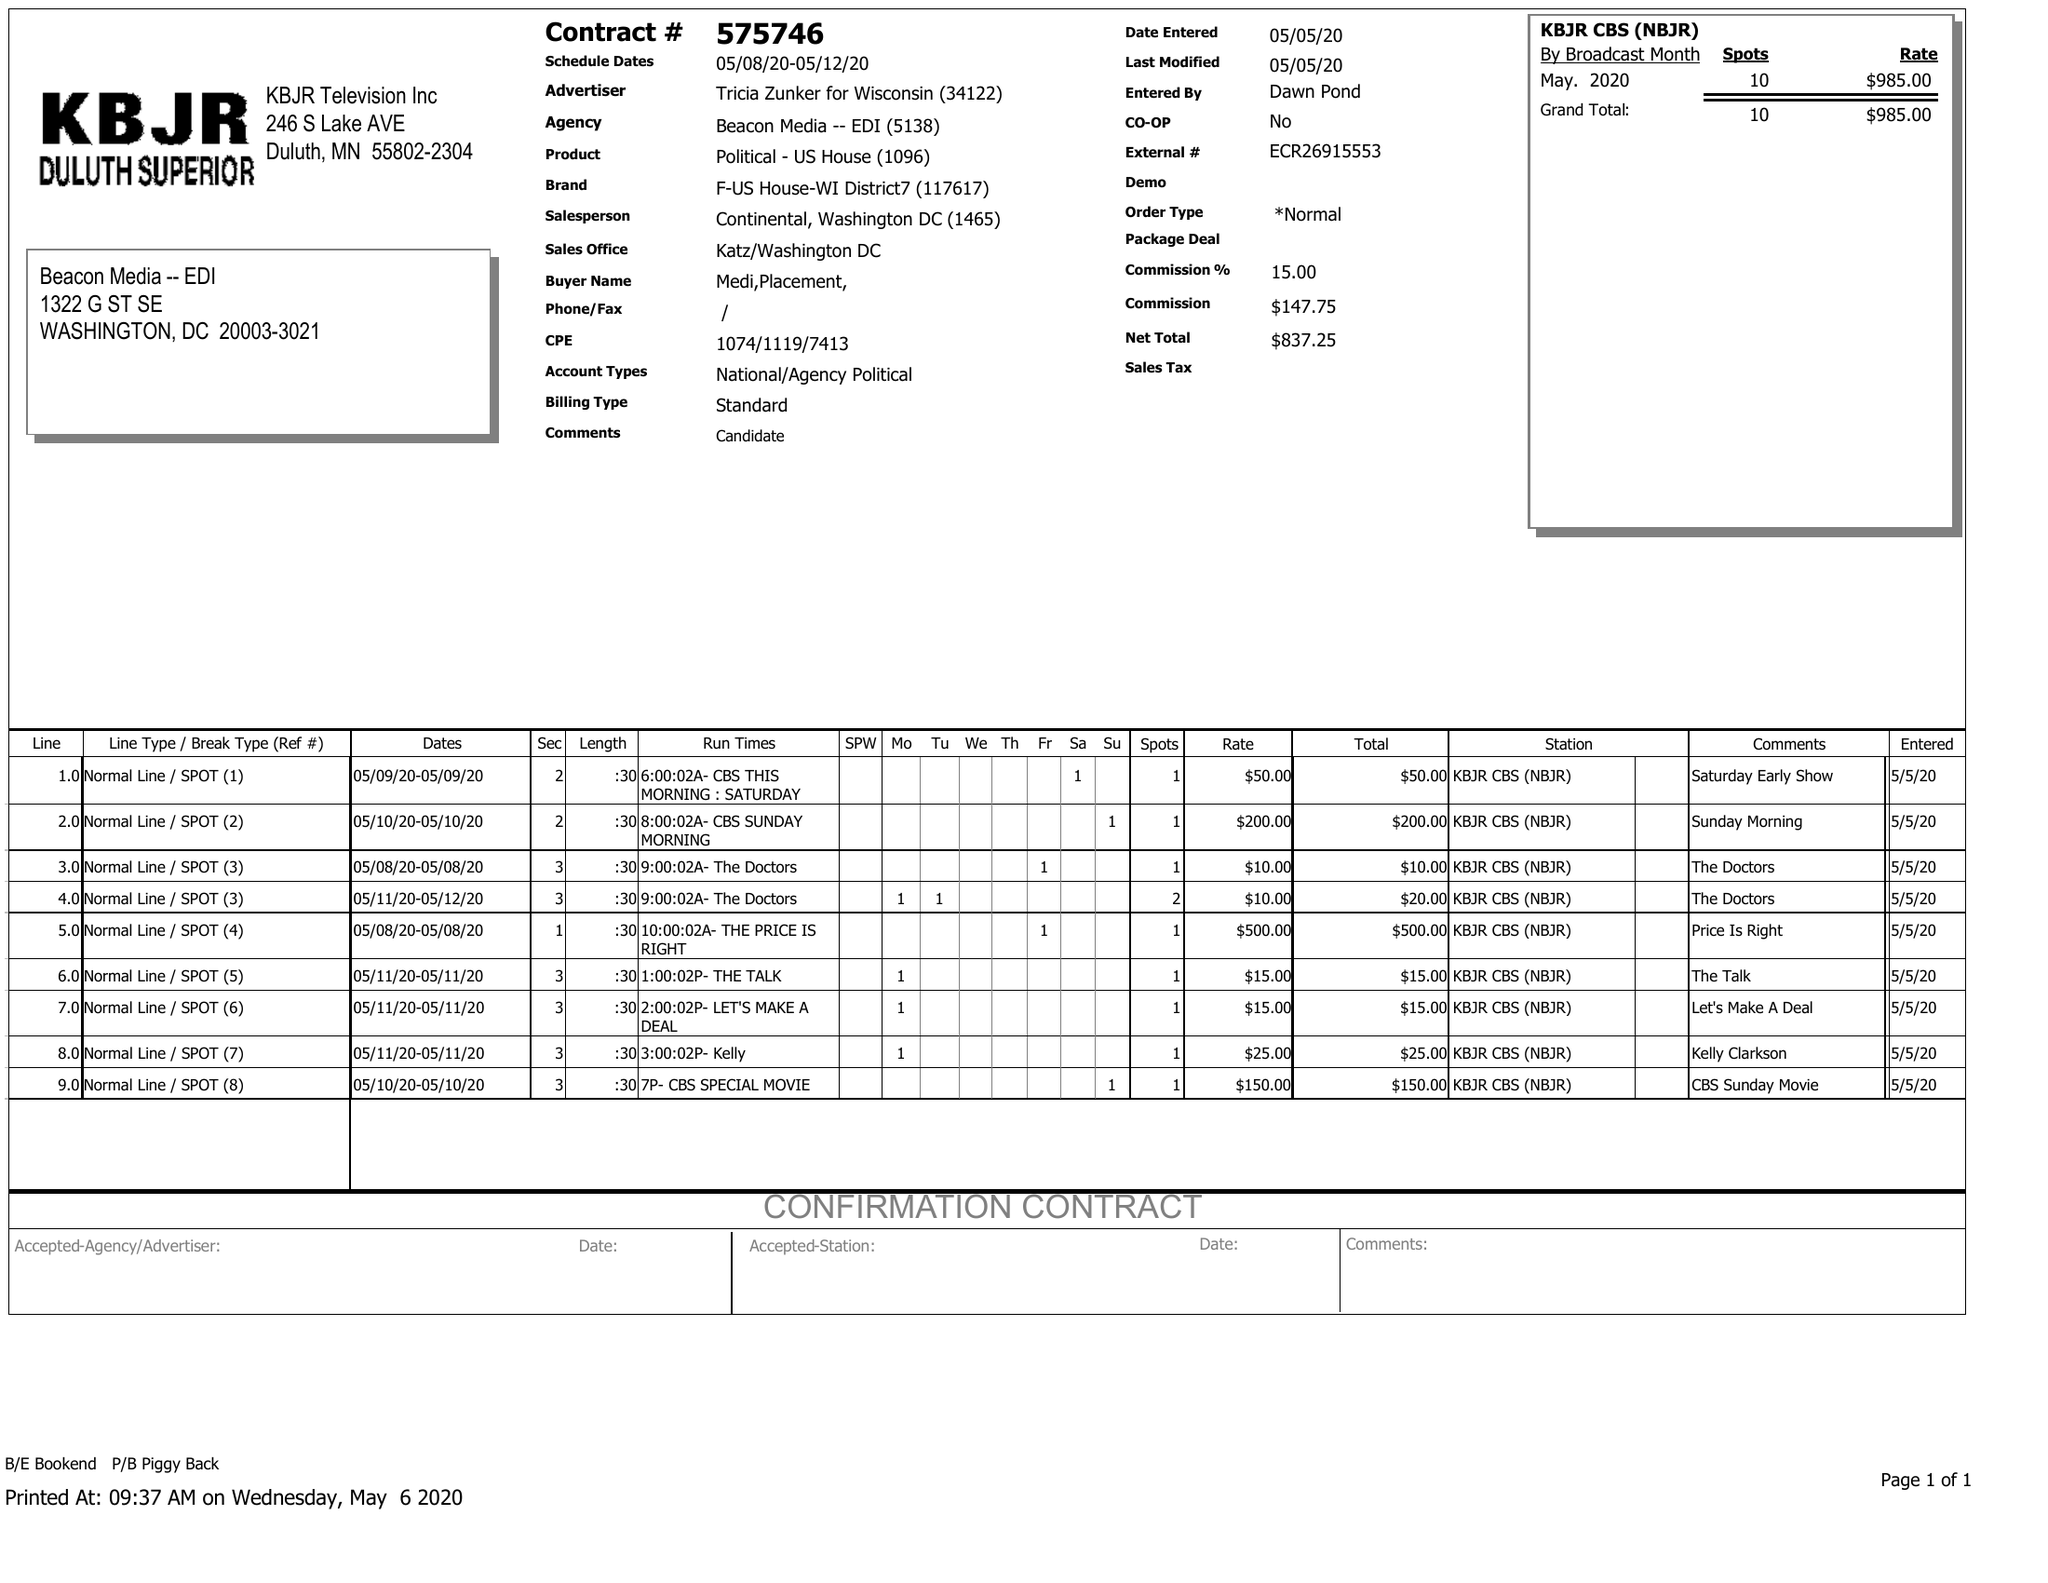What is the value for the advertiser?
Answer the question using a single word or phrase. TRICIA ZUNKER FOR WISCONSIN 